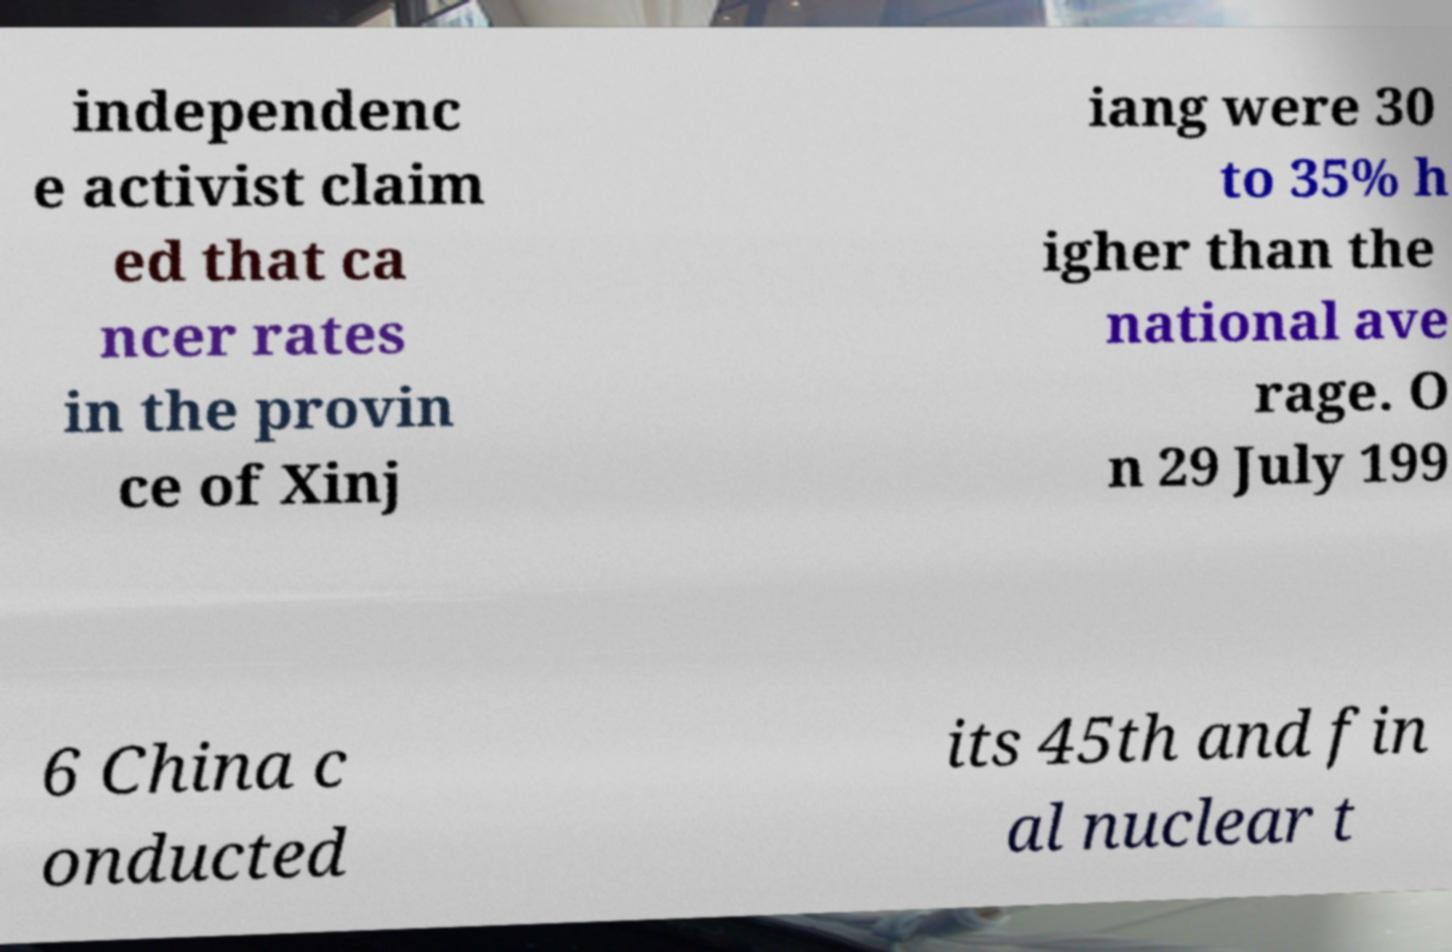Could you extract and type out the text from this image? independenc e activist claim ed that ca ncer rates in the provin ce of Xinj iang were 30 to 35% h igher than the national ave rage. O n 29 July 199 6 China c onducted its 45th and fin al nuclear t 